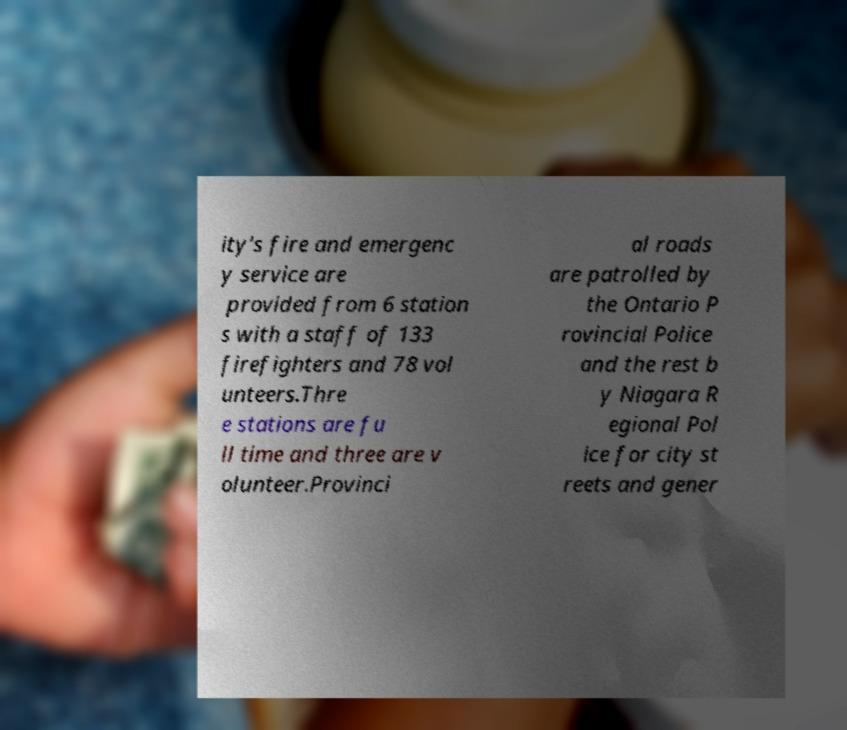Please read and relay the text visible in this image. What does it say? ity's fire and emergenc y service are provided from 6 station s with a staff of 133 firefighters and 78 vol unteers.Thre e stations are fu ll time and three are v olunteer.Provinci al roads are patrolled by the Ontario P rovincial Police and the rest b y Niagara R egional Pol ice for city st reets and gener 